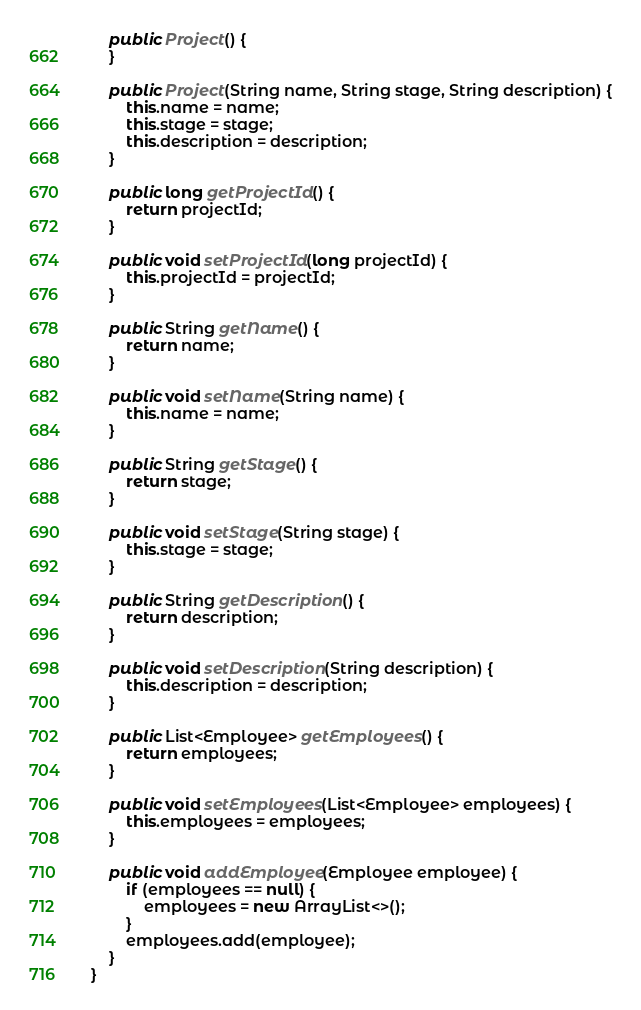<code> <loc_0><loc_0><loc_500><loc_500><_Java_>
    public Project() {
    }

    public Project(String name, String stage, String description) {
        this.name = name;
        this.stage = stage;
        this.description = description;
    }

    public long getProjectId() {
        return projectId;
    }

    public void setProjectId(long projectId) {
        this.projectId = projectId;
    }

    public String getName() {
        return name;
    }

    public void setName(String name) {
        this.name = name;
    }

    public String getStage() {
        return stage;
    }

    public void setStage(String stage) {
        this.stage = stage;
    }

    public String getDescription() {
        return description;
    }

    public void setDescription(String description) {
        this.description = description;
    }

    public List<Employee> getEmployees() {
        return employees;
    }

    public void setEmployees(List<Employee> employees) {
        this.employees = employees;
    }

    public void addEmployee(Employee employee) {
        if (employees == null) {
            employees = new ArrayList<>();
        }
        employees.add(employee);
    }
}
</code> 